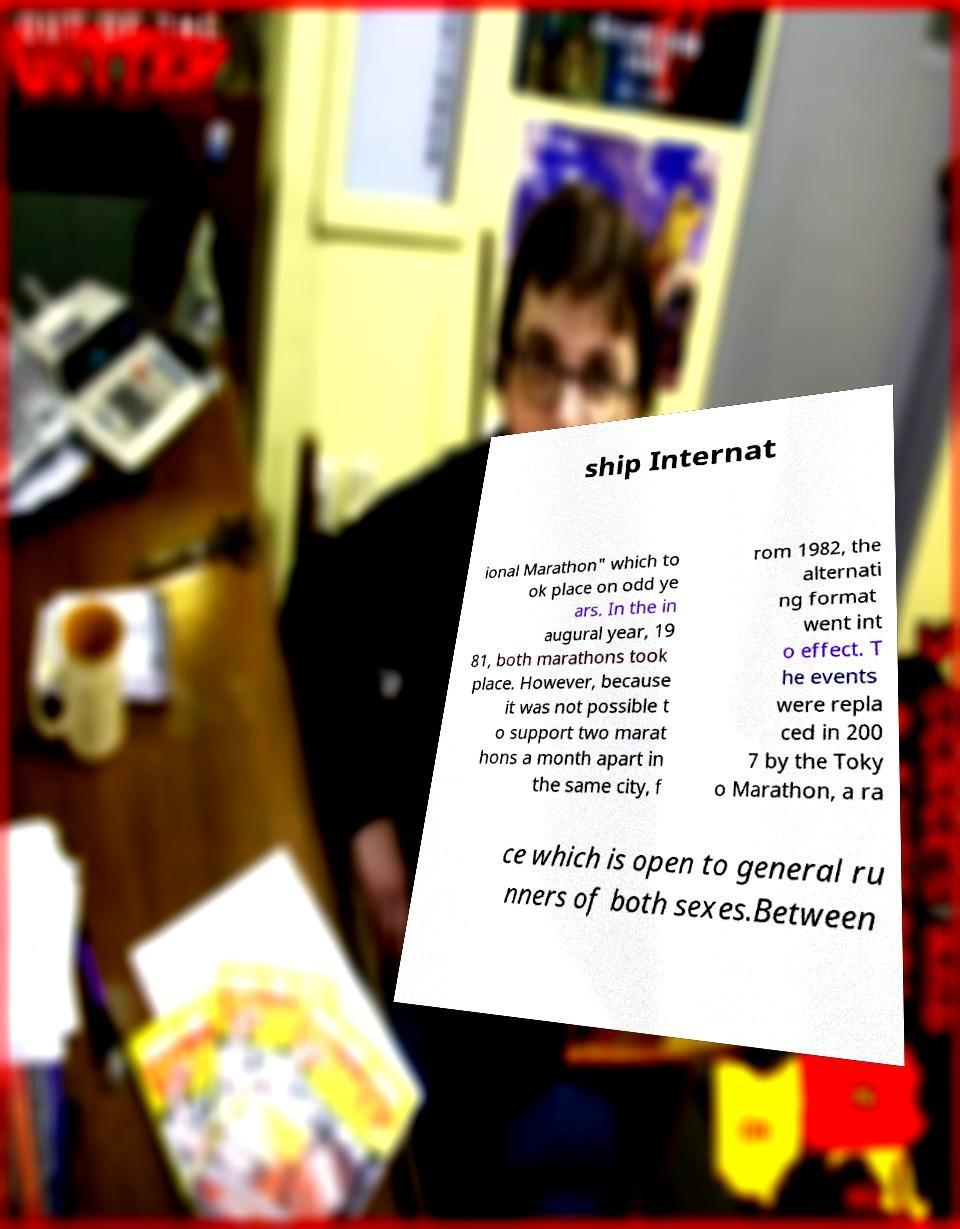Please read and relay the text visible in this image. What does it say? ship Internat ional Marathon" which to ok place on odd ye ars. In the in augural year, 19 81, both marathons took place. However, because it was not possible t o support two marat hons a month apart in the same city, f rom 1982, the alternati ng format went int o effect. T he events were repla ced in 200 7 by the Toky o Marathon, a ra ce which is open to general ru nners of both sexes.Between 